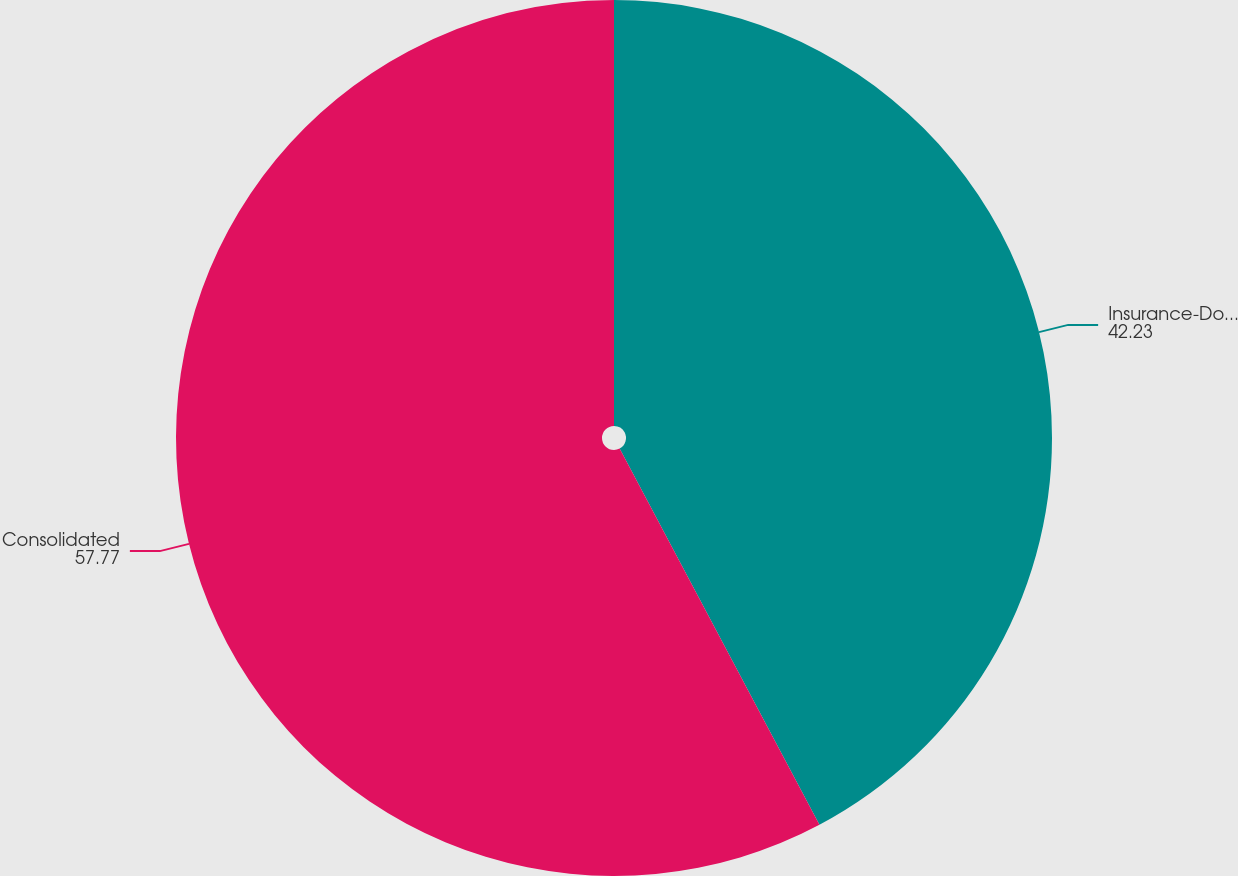<chart> <loc_0><loc_0><loc_500><loc_500><pie_chart><fcel>Insurance-Domestic<fcel>Consolidated<nl><fcel>42.23%<fcel>57.77%<nl></chart> 